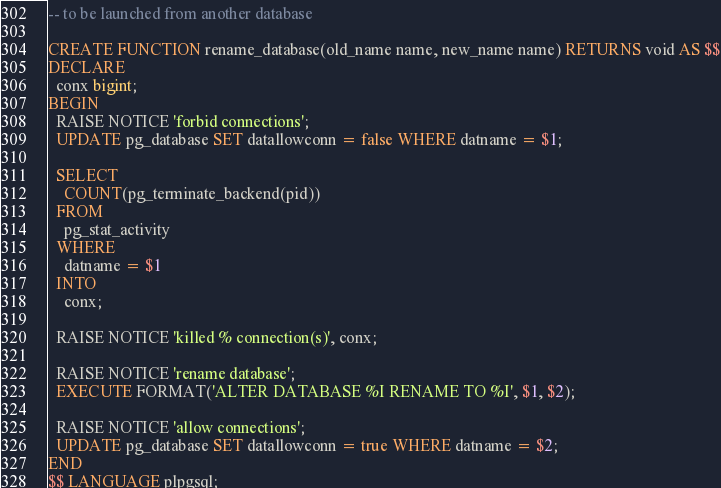Convert code to text. <code><loc_0><loc_0><loc_500><loc_500><_SQL_>-- to be launched from another database

CREATE FUNCTION rename_database(old_name name, new_name name) RETURNS void AS $$
DECLARE
  conx bigint;
BEGIN
  RAISE NOTICE 'forbid connections';
  UPDATE pg_database SET datallowconn = false WHERE datname = $1;

  SELECT
    COUNT(pg_terminate_backend(pid))
  FROM
    pg_stat_activity
  WHERE
    datname = $1
  INTO
    conx;

  RAISE NOTICE 'killed % connection(s)', conx;

  RAISE NOTICE 'rename database';
  EXECUTE FORMAT('ALTER DATABASE %I RENAME TO %I', $1, $2);

  RAISE NOTICE 'allow connections';
  UPDATE pg_database SET datallowconn = true WHERE datname = $2;
END
$$ LANGUAGE plpgsql;
</code> 